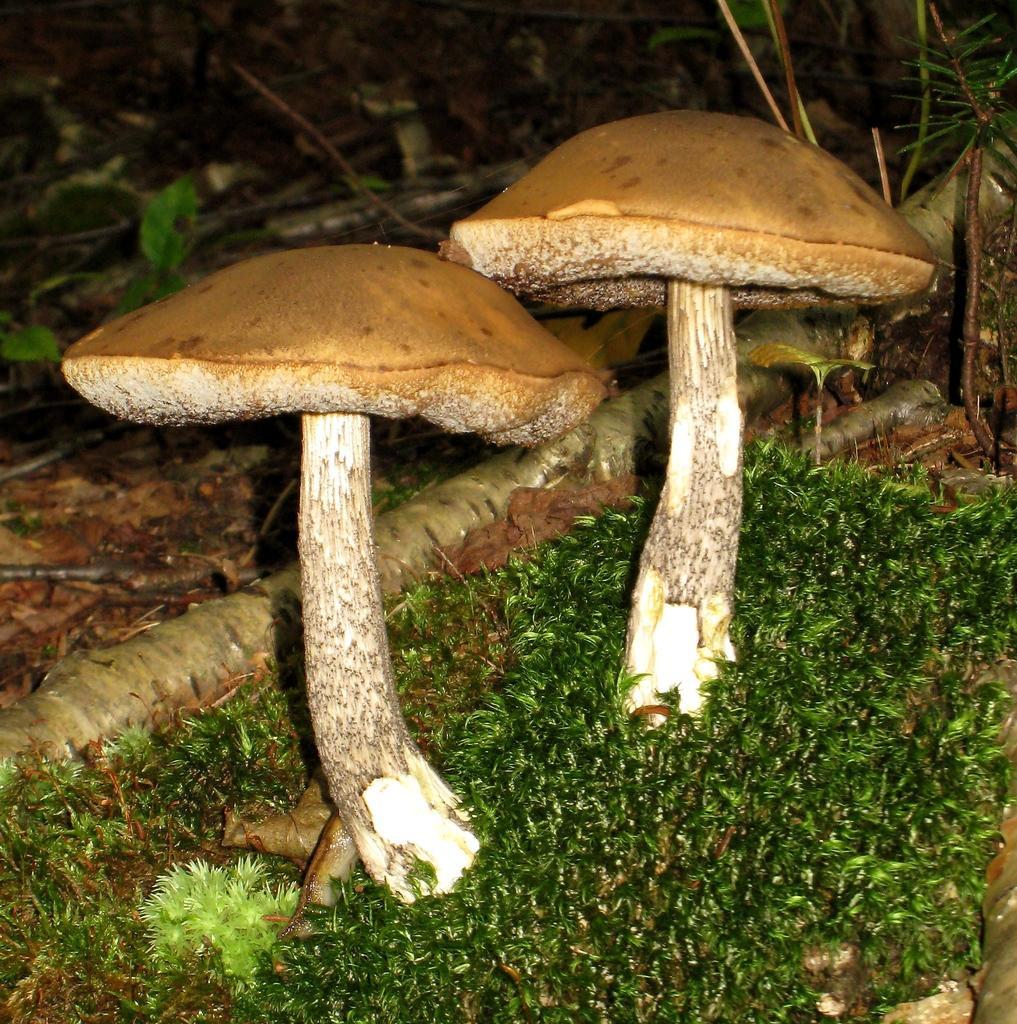Can you describe this image briefly? In the image there are two mushrooms, around the mushrooms there are small leaves. 